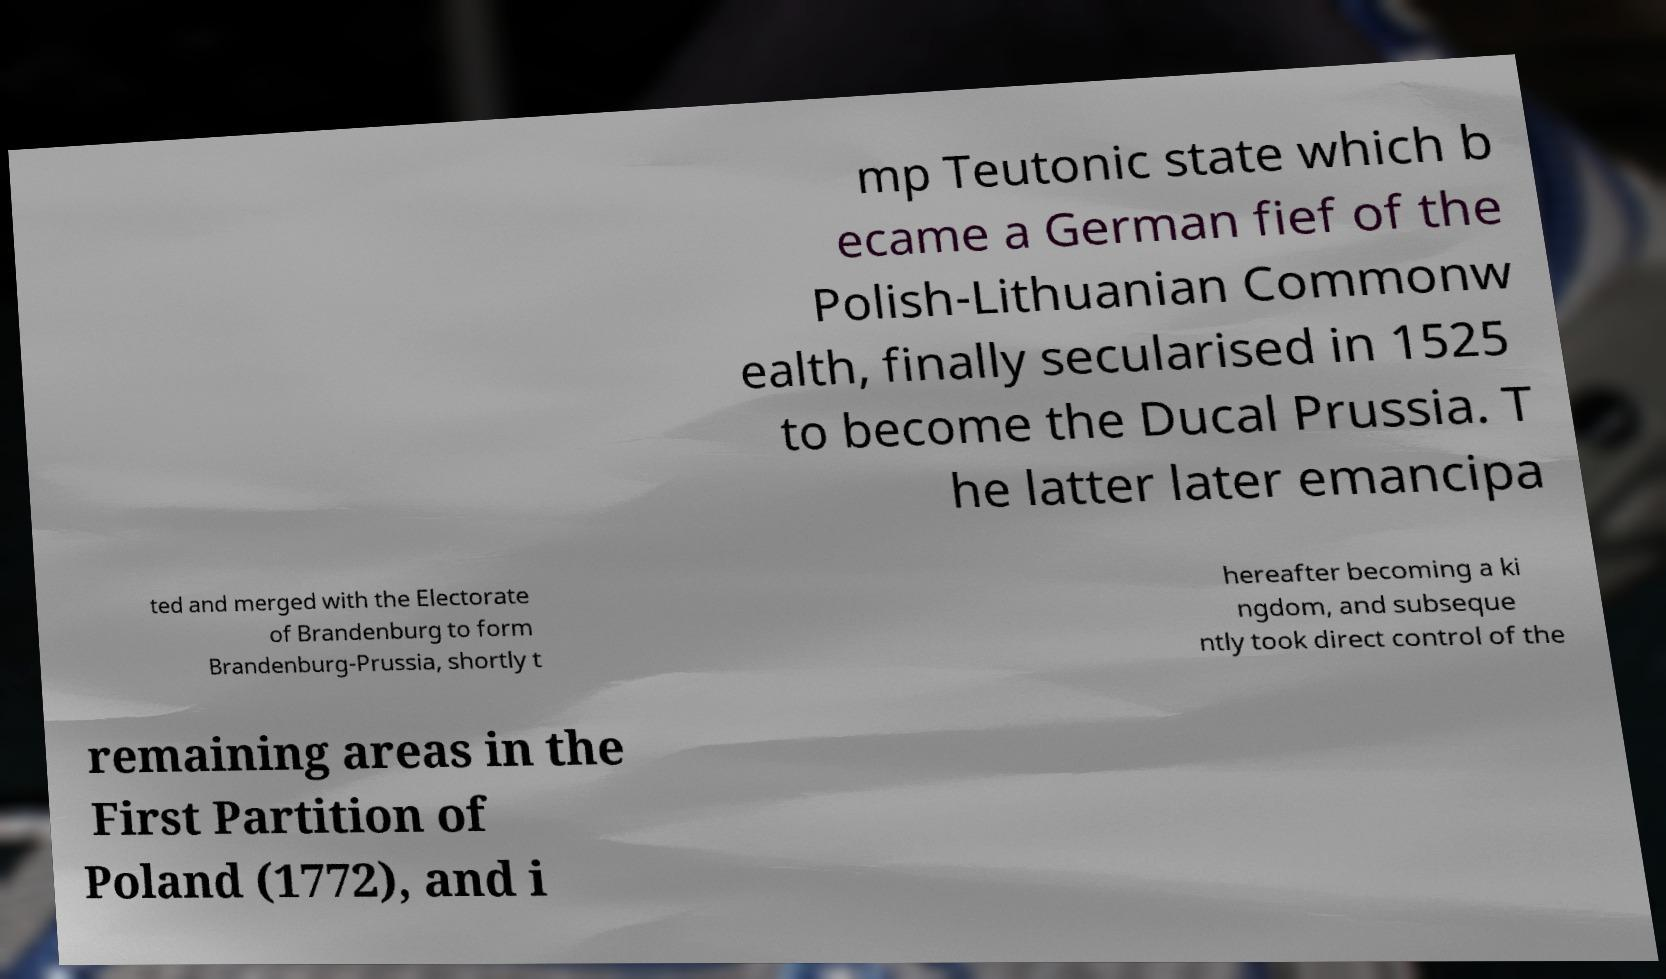Can you read and provide the text displayed in the image?This photo seems to have some interesting text. Can you extract and type it out for me? mp Teutonic state which b ecame a German fief of the Polish-Lithuanian Commonw ealth, finally secularised in 1525 to become the Ducal Prussia. T he latter later emancipa ted and merged with the Electorate of Brandenburg to form Brandenburg-Prussia, shortly t hereafter becoming a ki ngdom, and subseque ntly took direct control of the remaining areas in the First Partition of Poland (1772), and i 